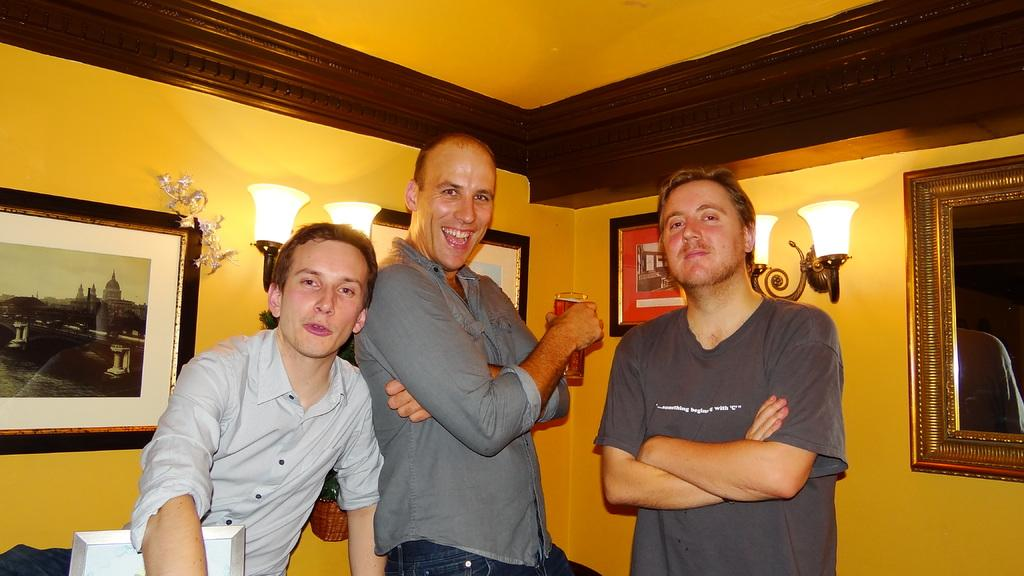What is happening in the image? There are people standing in the image. What is the man holding in his hand? The man is holding a glass in his hand. What can be seen on the wall in the image? There are photo frames on the wall. What can be seen providing illumination in the image? There are lights visible in the image. What type of soup is being served to the authority in the image? There is no soup or authority present in the image. What decisions is the committee making in the image? There is no committee present in the image. 